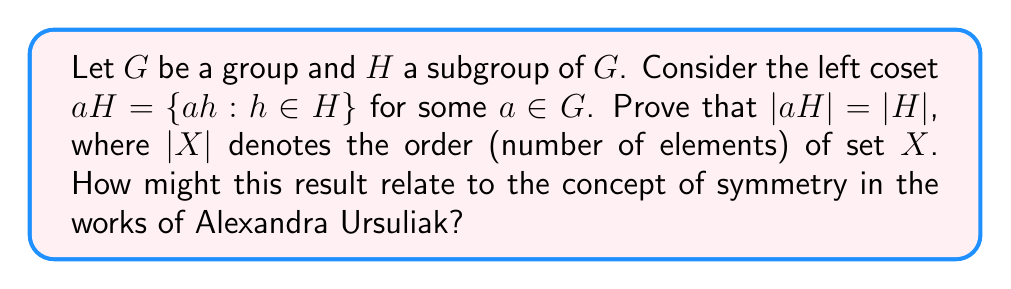Help me with this question. To prove that $|aH| = |H|$, we will show that there exists a bijection between $H$ and $aH$. This proof involves the following steps:

1) Define a function $f: H \rightarrow aH$ by $f(h) = ah$ for all $h \in H$.

2) Prove that $f$ is injective (one-to-one):
   Let $h_1, h_2 \in H$ such that $f(h_1) = f(h_2)$.
   Then $ah_1 = ah_2$
   Multiplying both sides by $a^{-1}$ (which exists since $G$ is a group), we get:
   $a^{-1}ah_1 = a^{-1}ah_2$
   $h_1 = h_2$
   Thus, $f$ is injective.

3) Prove that $f$ is surjective (onto):
   Let $y \in aH$. Then by definition of $aH$, there exists an $h \in H$ such that $y = ah = f(h)$.
   Thus, $f$ is surjective.

4) Since $f$ is both injective and surjective, it is a bijection.

5) The existence of a bijection between $H$ and $aH$ implies that they have the same number of elements, i.e., $|H| = |aH|$.

This result demonstrates a fundamental property of cosets: they preserve the size of the subgroup. In the context of Alexandra Ursuliak's work, this property might relate to the preservation of symmetry in her artistic designs. Just as cosets maintain the structure and size of a subgroup, Ursuliak's geometric patterns often maintain their symmetry when transformed or repeated across her canvas.
Answer: $|aH| = |H|$ for any $a \in G$ and subgroup $H$ of $G$, as proven by the bijection $f: H \rightarrow aH$ defined by $f(h) = ah$. 